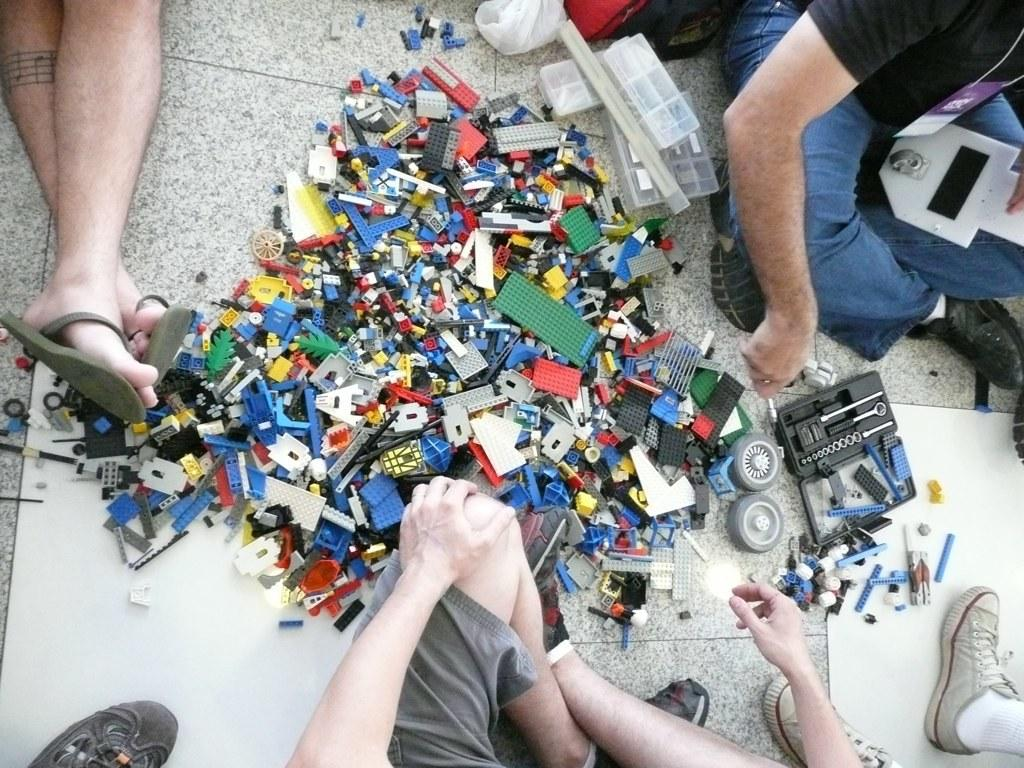What is located in the center of the image? There are logos placed on the floor in the center of the image. What body parts can be seen at the bottom of the image? Human legs and hands are visible at the bottom of the image. Where is the person located in the image? A person is present at the top of the image. What part of the person's body is visible at the top of the image? The legs of a person are visible at the top of the image. What type of music can be heard coming from the person's stomach in the image? There is no indication in the image that the person's stomach is producing music, so it cannot be determined from the picture. 